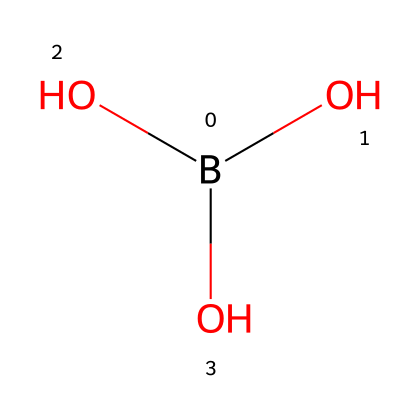What is the name of this chemical? The given SMILES representation corresponds to the chemical boric acid. Both the structure and common chemical nomenclature identify it.
Answer: boric acid How many oxygen atoms are in this compound? By analyzing the structure, we can see that there are three oxygen atoms indicated in the chemical formula. Each 'O' in the SMILES represents one oxygen atom.
Answer: three What is the total number of atoms in this chemical? The total number of atoms can be determined by counting: there is one boron atom, three oxygen atoms, and no hydrogen atoms explicitly shown in the SMILES. However, based on typical bonding patterns for this compound, we can infer that there are additional hydrogen atoms connected to the oxygen atoms (commonly represented in boric acid), totaling to seven.
Answer: seven Does this compound contain any metals? The structure contains only boron, which is considered a metalloid, not a metal. Thus, this compound does not exclusively contain metals.
Answer: no What is the primary function of boric acid in ancient Roman cosmetics? Boric acid was historically used for its antiseptic and anti-inflammatory properties in cosmetics, helping to soothe the skin.
Answer: antiseptic How might the structure of boric acid affect its reactivity in ancient applications? The presence of multiple hydroxyl groups (-OH) in boric acid makes it a weak acid, which can react with bases, leading to interactions that could enhance preservative effects in cosmetics.
Answer: weak acid In the context of ancient Roman cosmetics, what role might the boron atom play? The boron atom in boric acid contributes to its chemical bonding and overall stability, which is essential for maintaining the desired properties in cosmetic formulations.
Answer: stability 